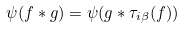<formula> <loc_0><loc_0><loc_500><loc_500>\psi ( f * g ) = \psi ( g * \tau _ { i \beta } ( f ) )</formula> 